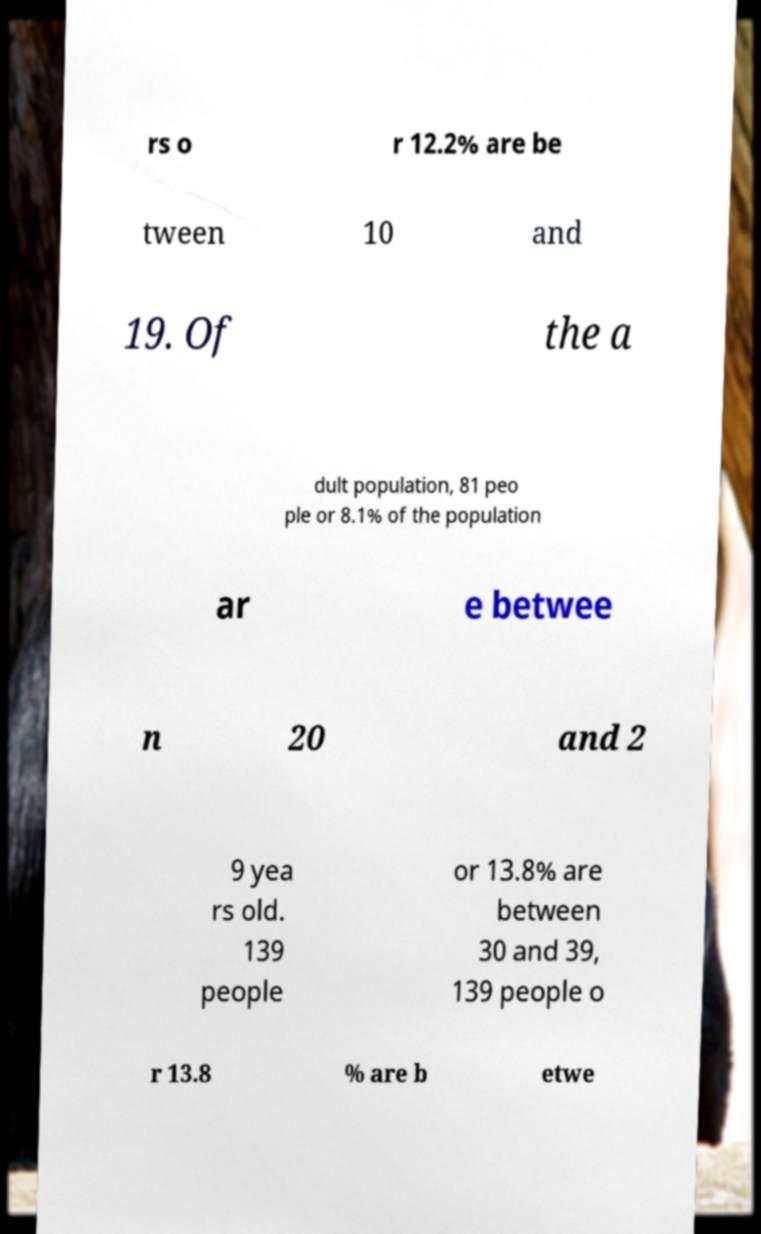I need the written content from this picture converted into text. Can you do that? rs o r 12.2% are be tween 10 and 19. Of the a dult population, 81 peo ple or 8.1% of the population ar e betwee n 20 and 2 9 yea rs old. 139 people or 13.8% are between 30 and 39, 139 people o r 13.8 % are b etwe 